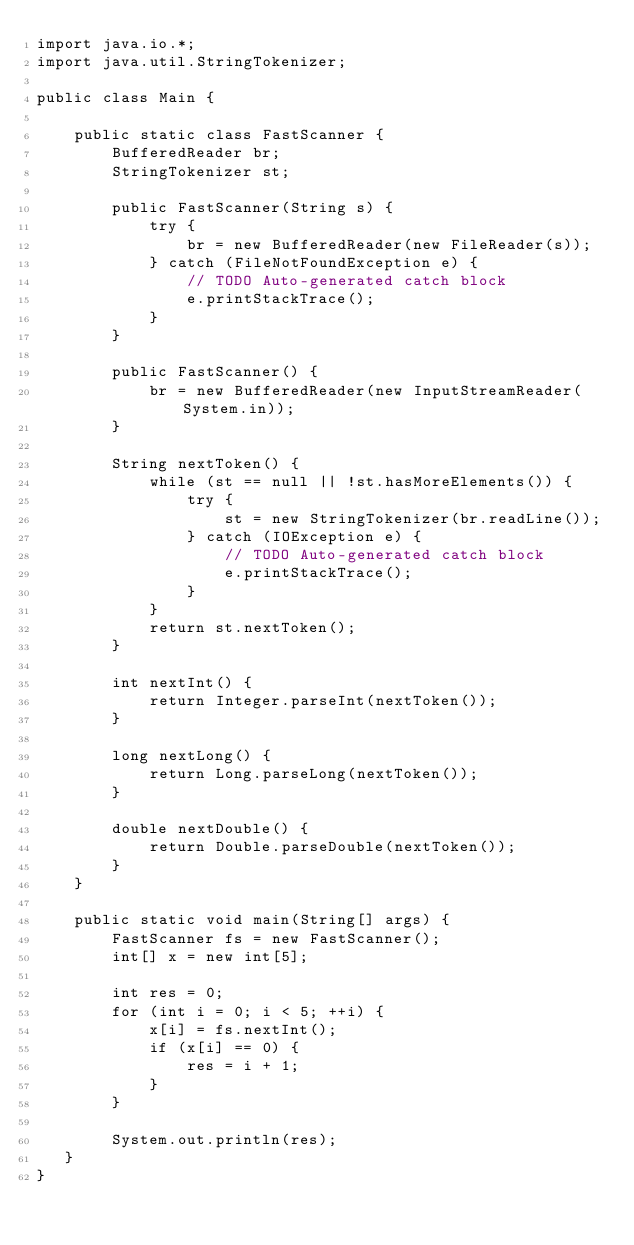<code> <loc_0><loc_0><loc_500><loc_500><_Java_>import java.io.*;
import java.util.StringTokenizer;

public class Main {

    public static class FastScanner {
        BufferedReader br;
        StringTokenizer st;

        public FastScanner(String s) {
            try {
                br = new BufferedReader(new FileReader(s));
            } catch (FileNotFoundException e) {
                // TODO Auto-generated catch block
                e.printStackTrace();
            }
        }

        public FastScanner() {
            br = new BufferedReader(new InputStreamReader(System.in));
        }

        String nextToken() {
            while (st == null || !st.hasMoreElements()) {
                try {
                    st = new StringTokenizer(br.readLine());
                } catch (IOException e) {
                    // TODO Auto-generated catch block
                    e.printStackTrace();
                }
            }
            return st.nextToken();
        }

        int nextInt() {
            return Integer.parseInt(nextToken());
        }

        long nextLong() {
            return Long.parseLong(nextToken());
        }

        double nextDouble() {
            return Double.parseDouble(nextToken());
        }
    }

    public static void main(String[] args) {
        FastScanner fs = new FastScanner();
        int[] x = new int[5];

        int res = 0;
        for (int i = 0; i < 5; ++i) {
            x[i] = fs.nextInt();
            if (x[i] == 0) {
                res = i + 1;
            }
        }

        System.out.println(res);
   }
}
</code> 